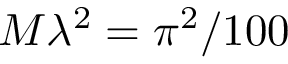<formula> <loc_0><loc_0><loc_500><loc_500>M \lambda ^ { 2 } = \pi ^ { 2 } / 1 0 0</formula> 